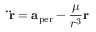<formula> <loc_0><loc_0><loc_500><loc_500>\ddot { r } = a _ { p e r } - { \frac { \mu } { r ^ { 3 } } } r</formula> 